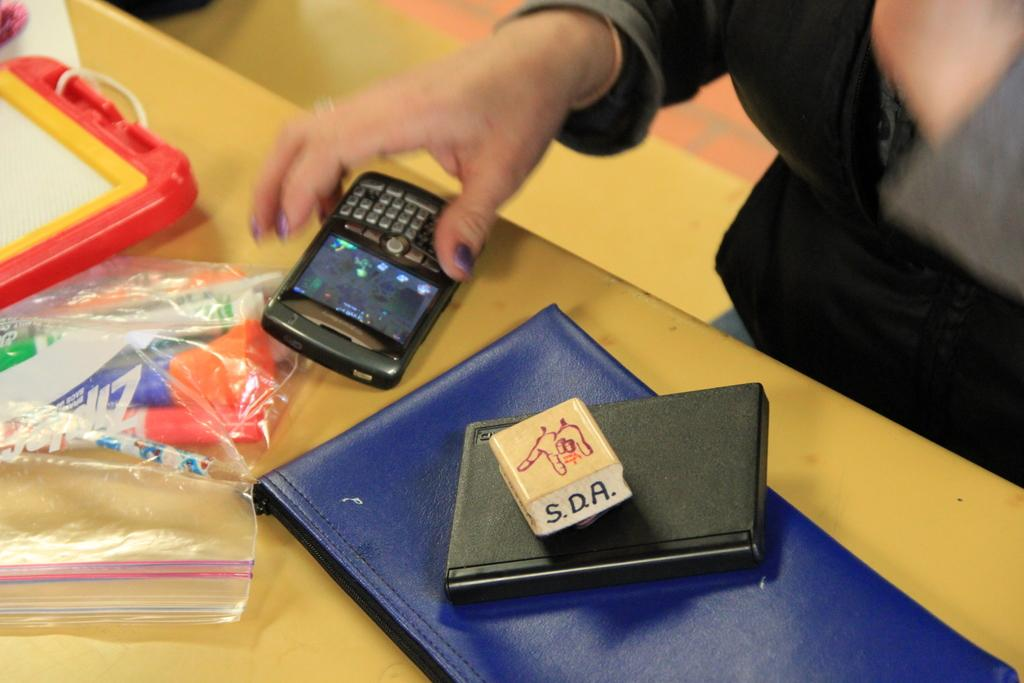<image>
Relay a brief, clear account of the picture shown. A woman touches her phone next to a plastic bag with Ziplock printed on it. 